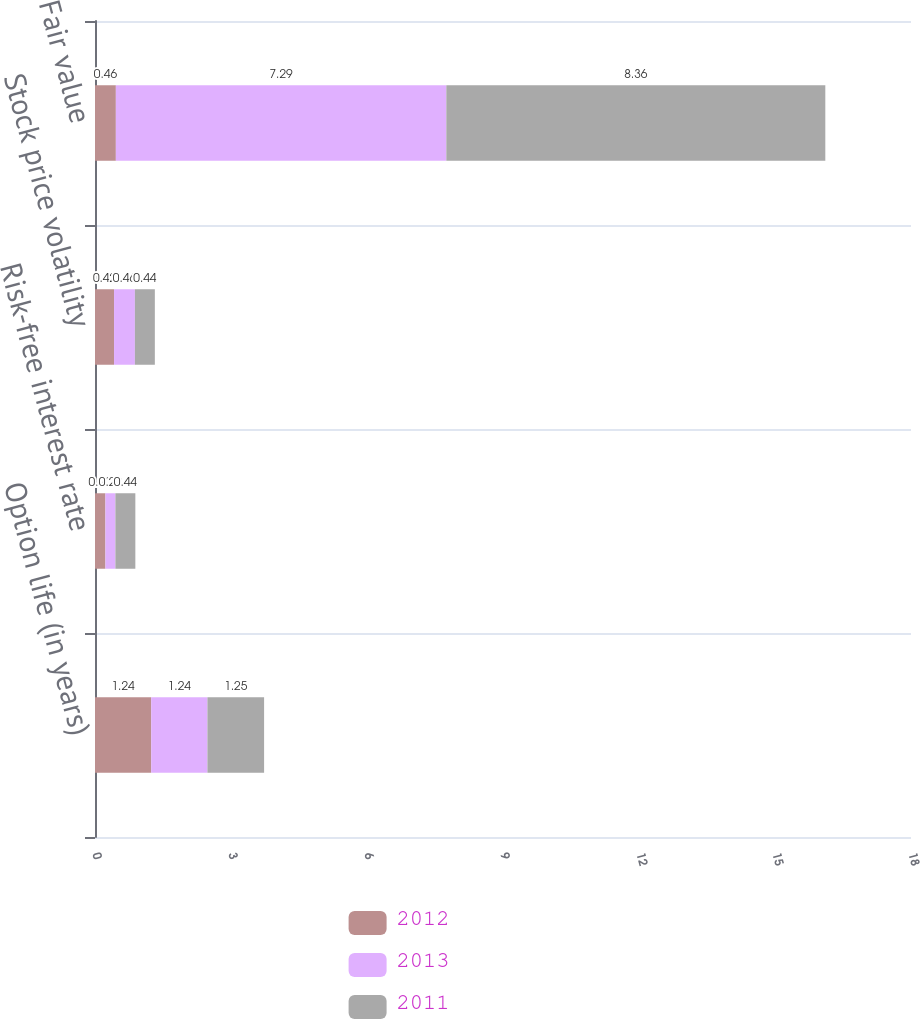<chart> <loc_0><loc_0><loc_500><loc_500><stacked_bar_chart><ecel><fcel>Option life (in years)<fcel>Risk-free interest rate<fcel>Stock price volatility<fcel>Fair value<nl><fcel>2012<fcel>1.24<fcel>0.23<fcel>0.42<fcel>0.46<nl><fcel>2013<fcel>1.24<fcel>0.22<fcel>0.46<fcel>7.29<nl><fcel>2011<fcel>1.25<fcel>0.44<fcel>0.44<fcel>8.36<nl></chart> 